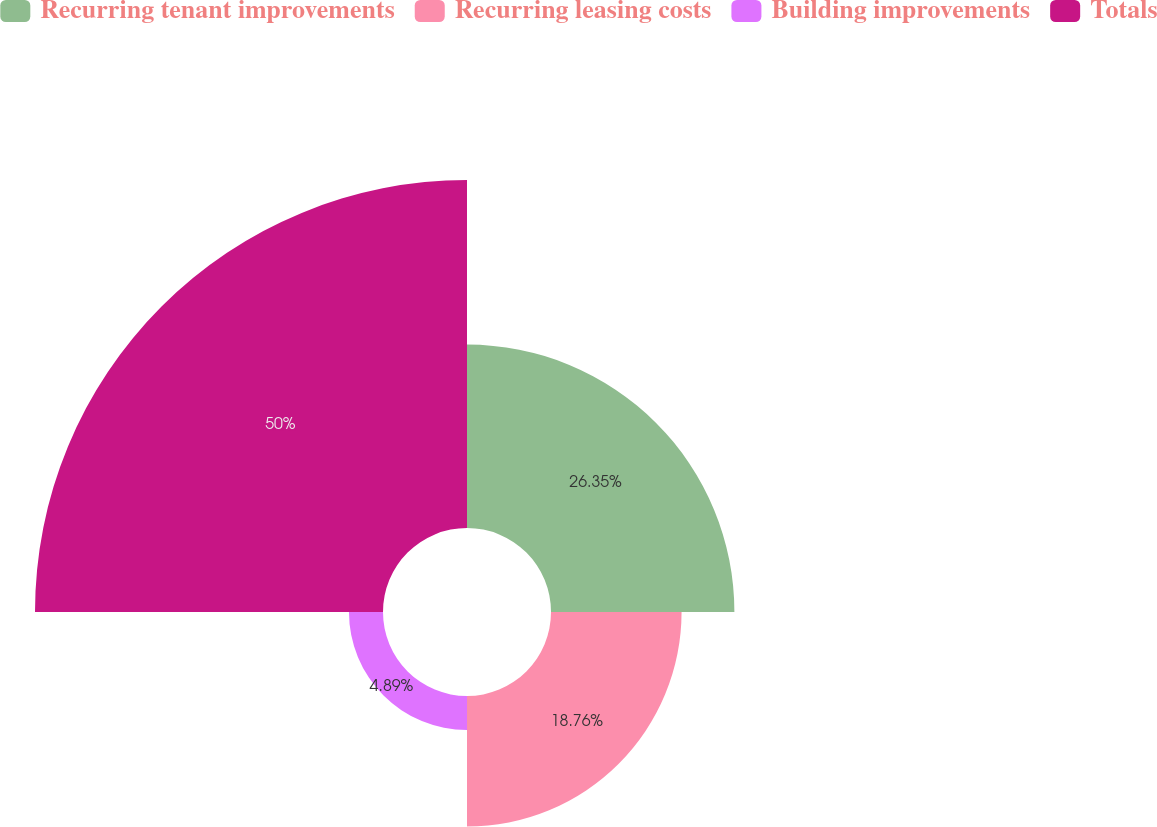Convert chart to OTSL. <chart><loc_0><loc_0><loc_500><loc_500><pie_chart><fcel>Recurring tenant improvements<fcel>Recurring leasing costs<fcel>Building improvements<fcel>Totals<nl><fcel>26.35%<fcel>18.76%<fcel>4.89%<fcel>50.0%<nl></chart> 